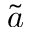Convert formula to latex. <formula><loc_0><loc_0><loc_500><loc_500>\tilde { a }</formula> 